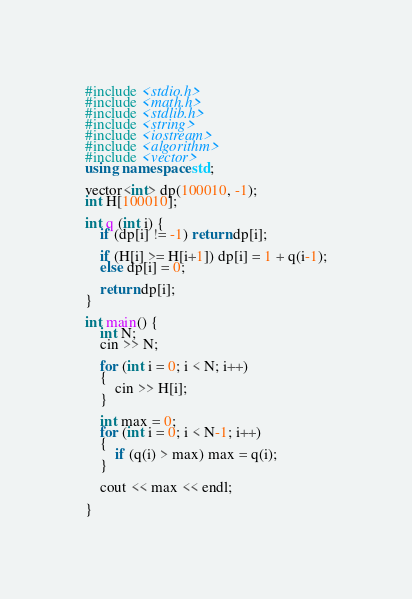Convert code to text. <code><loc_0><loc_0><loc_500><loc_500><_C++_>#include <stdio.h>
#include <math.h>
#include <stdlib.h>
#include <string>
#include <iostream>
#include <algorithm>
#include <vector>
using namespace std;

vector<int> dp(100010, -1);
int H[100010];

int q (int i) {
    if (dp[i] != -1) return dp[i];

    if (H[i] >= H[i+1]) dp[i] = 1 + q(i-1);
    else dp[i] = 0;

    return dp[i];
}

int main() {
    int N;
    cin >> N;

    for (int i = 0; i < N; i++)
    {
        cin >> H[i];
    }

    int max = 0;
    for (int i = 0; i < N-1; i++)
    {
        if (q(i) > max) max = q(i);
    }
    
    cout << max << endl;

}</code> 